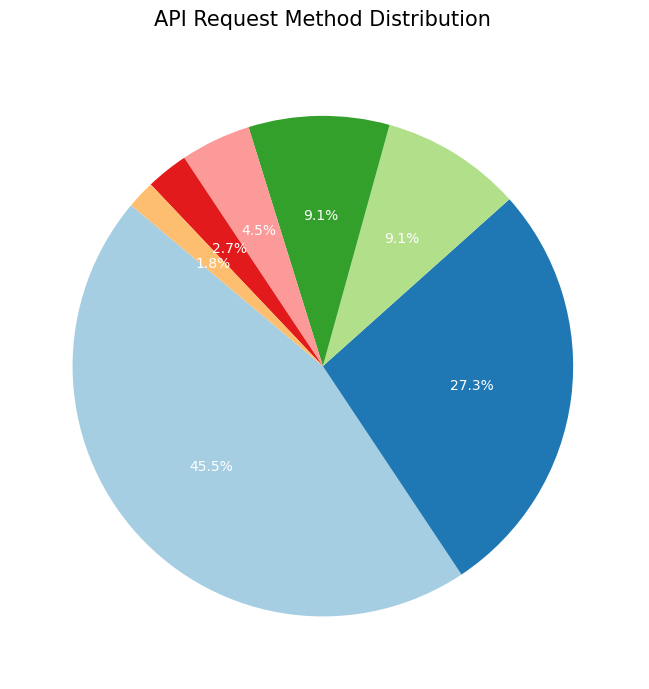What's the most common API request method? The pie chart shows the percentages of different API request methods, with the largest slice representing 50% for the GET method, making it the most common.
Answer: GET Which API request methods have the same percentage? The pie chart indicates that both PUT and DELETE methods have a 10% share, evidenced by their equal-sized sections in the chart.
Answer: PUT and DELETE What is the combined percentage of the least common methods? The least common methods PATCH and HEAD have percentages of 2% and 3% respectively. Summing these gives 2% + 3% = 5%.
Answer: 5% How much larger is the percentage of GET requests compared to POST requests? The pie chart shows GET requests at 50% and POST requests at 30%. The difference in their percentages is 50% - 30% = 20%.
Answer: 20% Are there more OPTIONS or PUT requests? The pie chart indicates that OPTIONS requests have a 5% share, while PUT requests have a 10% share. Therefore, there are more PUT requests.
Answer: PUT What percentage of requests are either HEAD or PATCH methods? Summing the percentages of HEAD (3%) and PATCH (2%) methods gives 3% + 2% = 5%.
Answer: 5% Which method accounts for the smallest percentage of requests? The pie chart shows that the PATCH method has the smallest percentage, accounting for 2% of the total requests.
Answer: PATCH Does the POST method have a higher or lower percentage than OPTIONS? The pie chart shows that POST requests make up 30%, while OPTIONS requests are at 5%, indicating that POST has a higher percentage.
Answer: Higher What is the total percentage of methods other than GET? Subtracting the GET percentage (50%) from 100% gives the combined percentage for the other methods: 100% - 50% = 50%.
Answer: 50% 